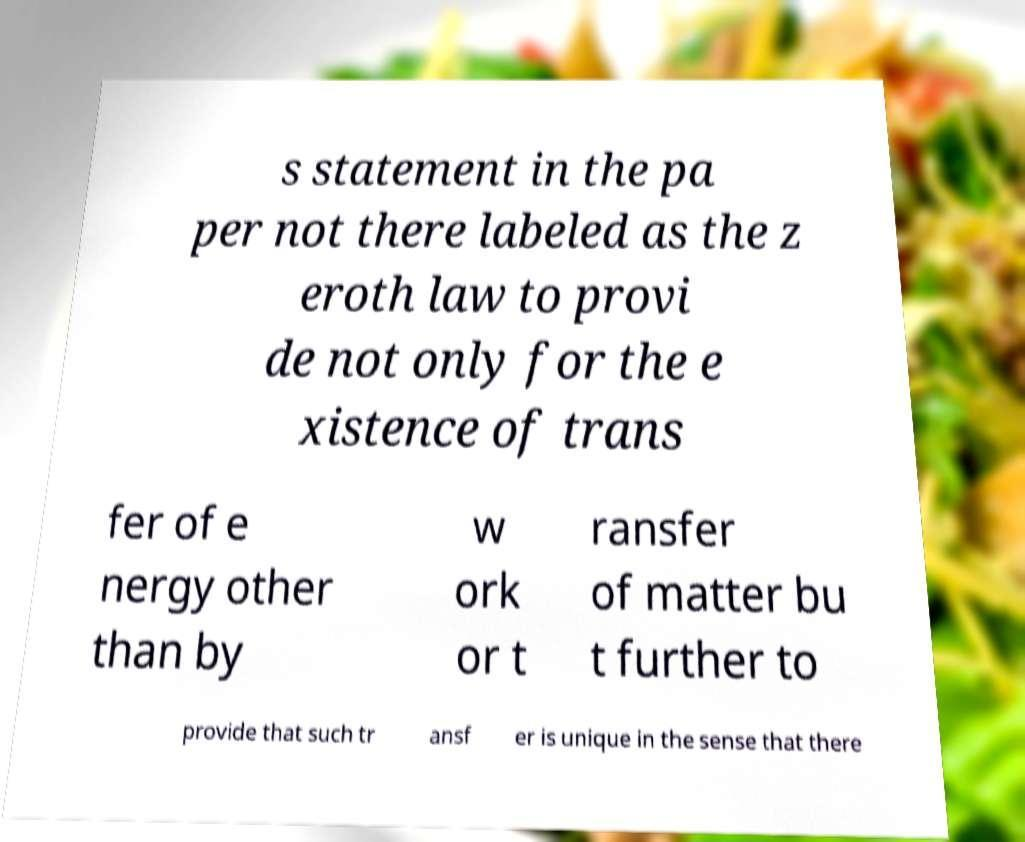I need the written content from this picture converted into text. Can you do that? s statement in the pa per not there labeled as the z eroth law to provi de not only for the e xistence of trans fer of e nergy other than by w ork or t ransfer of matter bu t further to provide that such tr ansf er is unique in the sense that there 